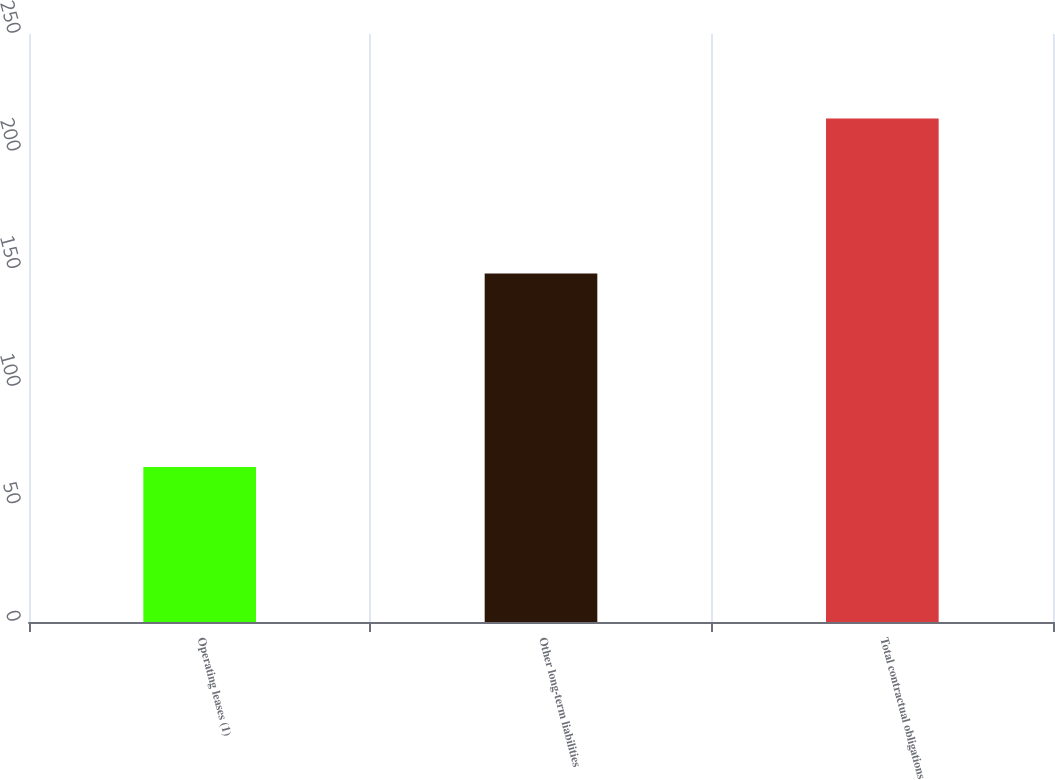Convert chart. <chart><loc_0><loc_0><loc_500><loc_500><bar_chart><fcel>Operating leases (1)<fcel>Other long-term liabilities<fcel>Total contractual obligations<nl><fcel>65.9<fcel>148.2<fcel>214.1<nl></chart> 